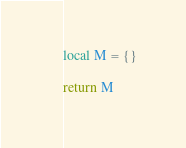<code> <loc_0><loc_0><loc_500><loc_500><_Lua_>
local M = {}

return M

</code> 